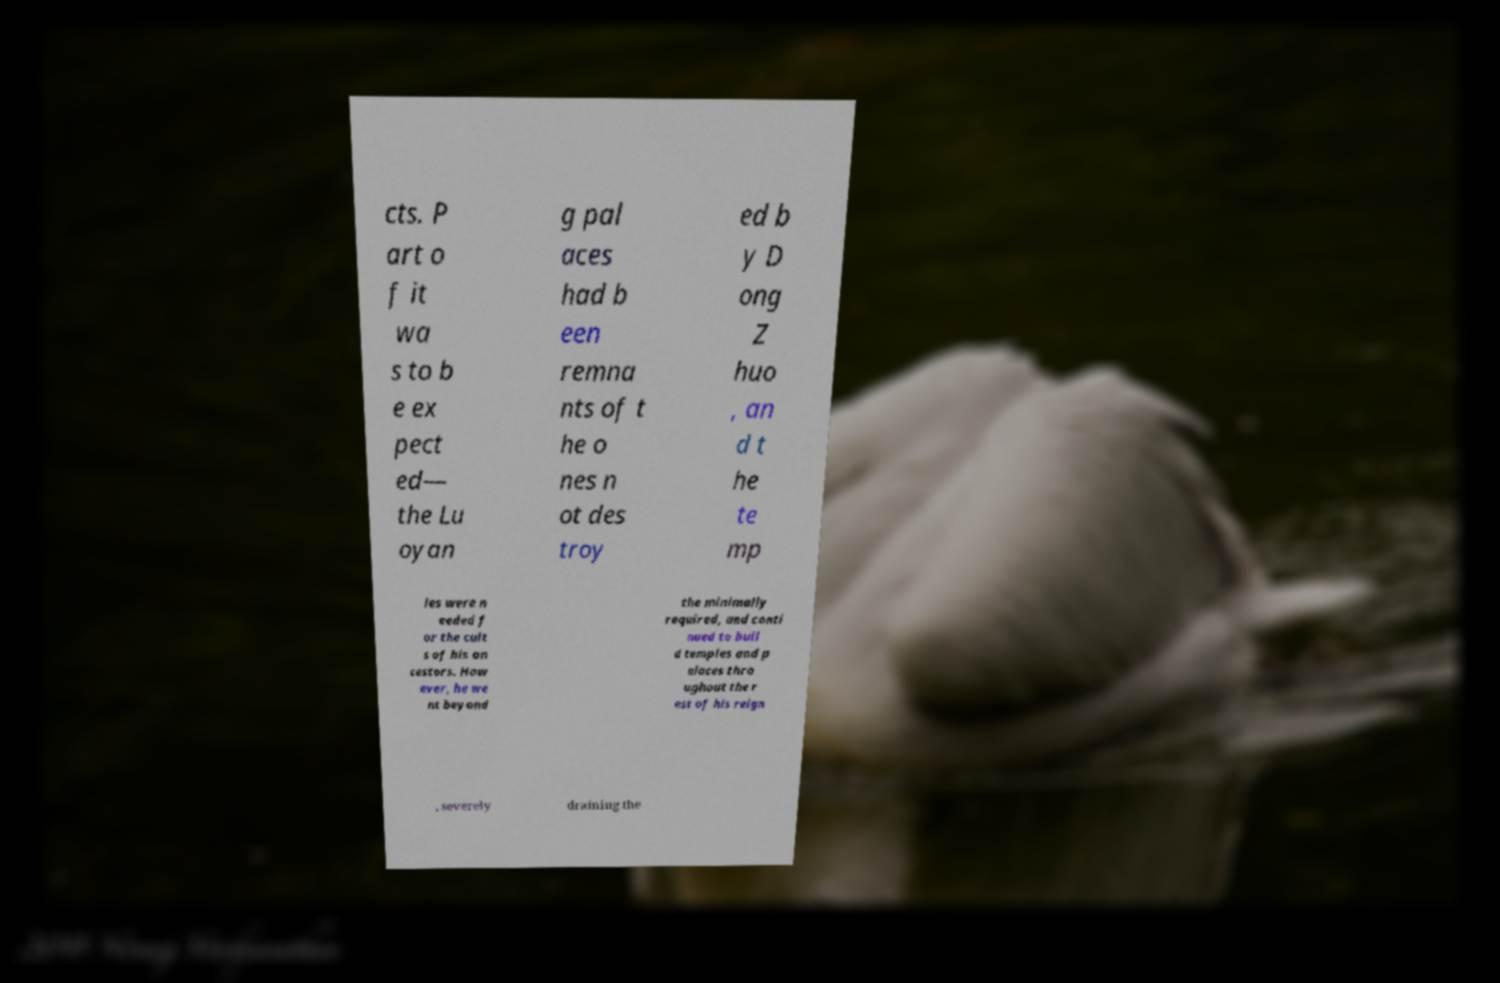Could you extract and type out the text from this image? cts. P art o f it wa s to b e ex pect ed— the Lu oyan g pal aces had b een remna nts of t he o nes n ot des troy ed b y D ong Z huo , an d t he te mp les were n eeded f or the cult s of his an cestors. How ever, he we nt beyond the minimally required, and conti nued to buil d temples and p alaces thro ughout the r est of his reign , severely draining the 